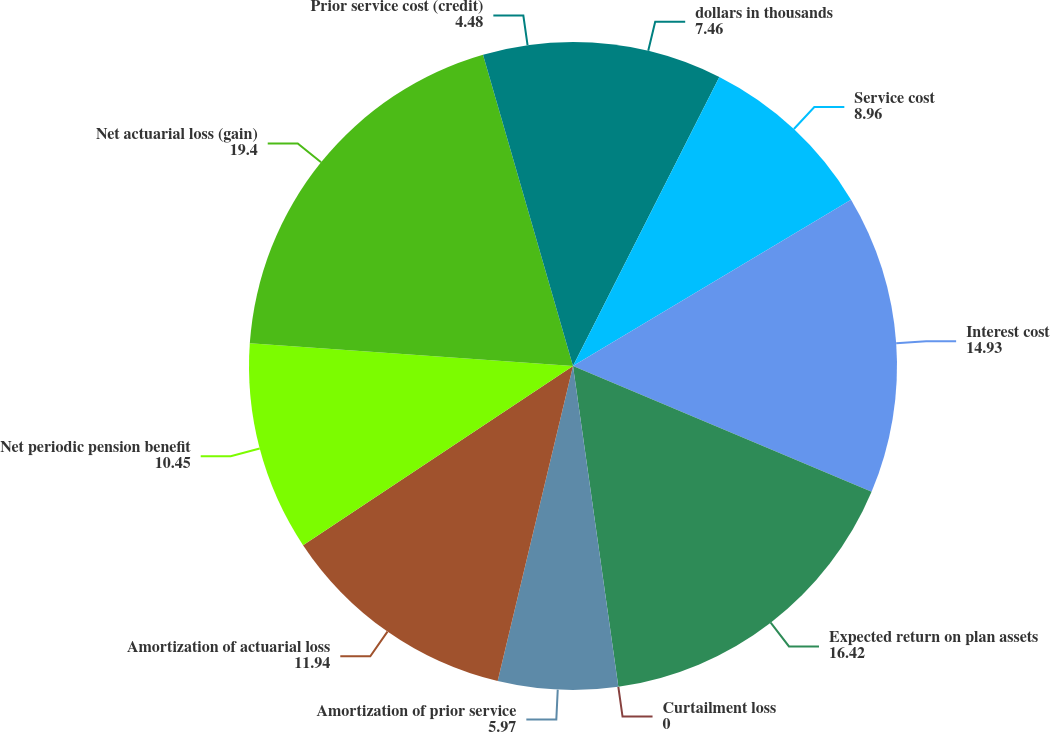Convert chart to OTSL. <chart><loc_0><loc_0><loc_500><loc_500><pie_chart><fcel>dollars in thousands<fcel>Service cost<fcel>Interest cost<fcel>Expected return on plan assets<fcel>Curtailment loss<fcel>Amortization of prior service<fcel>Amortization of actuarial loss<fcel>Net periodic pension benefit<fcel>Net actuarial loss (gain)<fcel>Prior service cost (credit)<nl><fcel>7.46%<fcel>8.96%<fcel>14.93%<fcel>16.42%<fcel>0.0%<fcel>5.97%<fcel>11.94%<fcel>10.45%<fcel>19.4%<fcel>4.48%<nl></chart> 